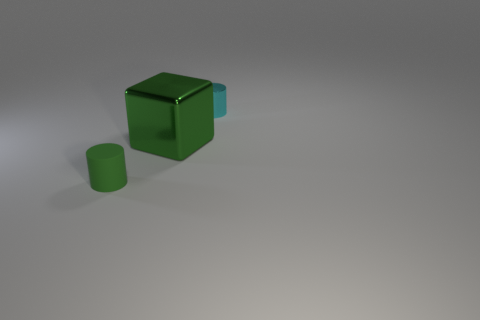There is a small thing that is in front of the small cyan cylinder; is its shape the same as the tiny cyan metal thing?
Offer a terse response. Yes. What material is the other cylinder that is the same size as the green rubber cylinder?
Give a very brief answer. Metal. Are there the same number of green cylinders behind the green rubber cylinder and cyan things to the left of the small metallic object?
Offer a very short reply. Yes. There is a metal object behind the metal object left of the metal cylinder; how many small cyan things are in front of it?
Provide a succinct answer. 0. Is the color of the tiny rubber object the same as the large metallic thing right of the rubber object?
Ensure brevity in your answer.  Yes. There is another cyan thing that is made of the same material as the big object; what is its size?
Offer a very short reply. Small. Are there more large green cubes that are in front of the small rubber thing than tiny objects?
Offer a very short reply. No. What material is the object behind the metal thing that is in front of the tiny object behind the rubber thing made of?
Your answer should be compact. Metal. Does the tiny green cylinder have the same material as the cylinder that is to the right of the green shiny thing?
Keep it short and to the point. No. There is a tiny green object that is the same shape as the tiny cyan metallic thing; what material is it?
Your answer should be compact. Rubber. 